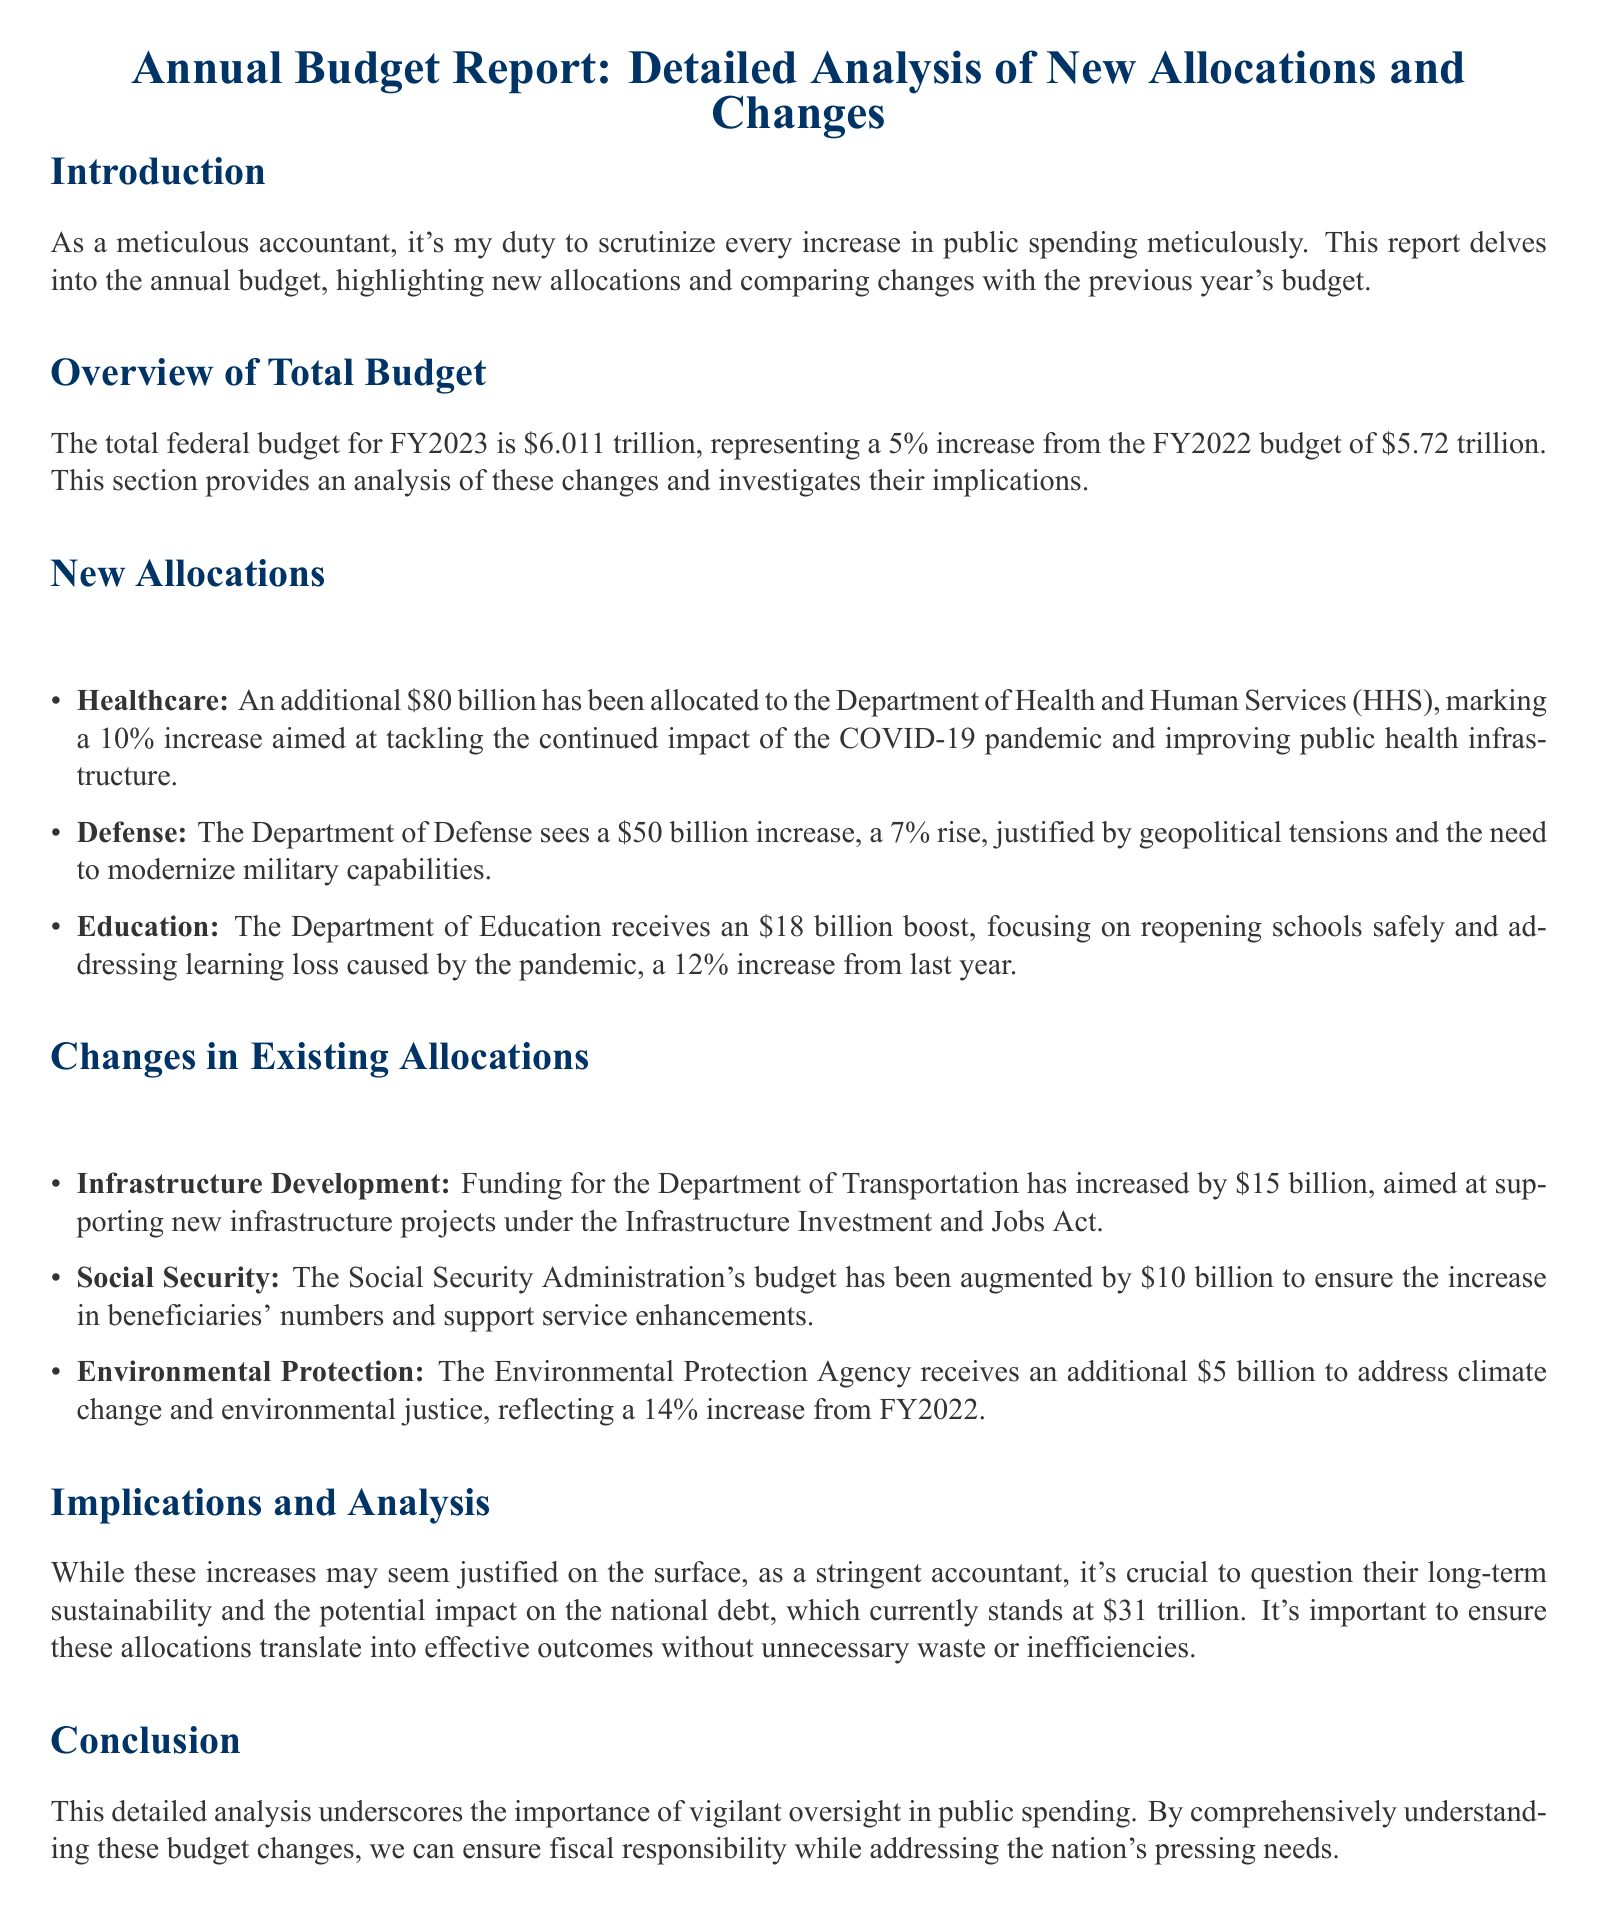What is the total federal budget for FY2023? The document states that the total federal budget for FY2023 is $6.011 trillion.
Answer: $6.011 trillion What is the increase in allocation for healthcare? The document indicates an additional $80 billion allocated to healthcare, representing a 10% increase.
Answer: $80 billion How much has the Department of Defense's budget increased by? The increase in the Department of Defense's budget is stated as $50 billion.
Answer: $50 billion What percentage increase is allocated to Education? The document mentions that Education receives a 12% increase from last year.
Answer: 12% What is the funding increase for Environmental Protection? The document specifies that an additional $5 billion is allocated for Environmental Protection.
Answer: $5 billion What is the main concern regarding the budget increases? The analysis raises concerns about the long-term sustainability and impact on the national debt.
Answer: Long-term sustainability What was the previous year's budget for comparison? The document provides the previous year's budget as $5.72 trillion for FY2022.
Answer: $5.72 trillion What justification is provided for the increase in Defense budget? The justification mentioned for the increase in the Defense budget is geopolitical tensions.
Answer: Geopolitical tensions What is the current national debt mentioned in the document? The document states that the current national debt is $31 trillion.
Answer: $31 trillion 